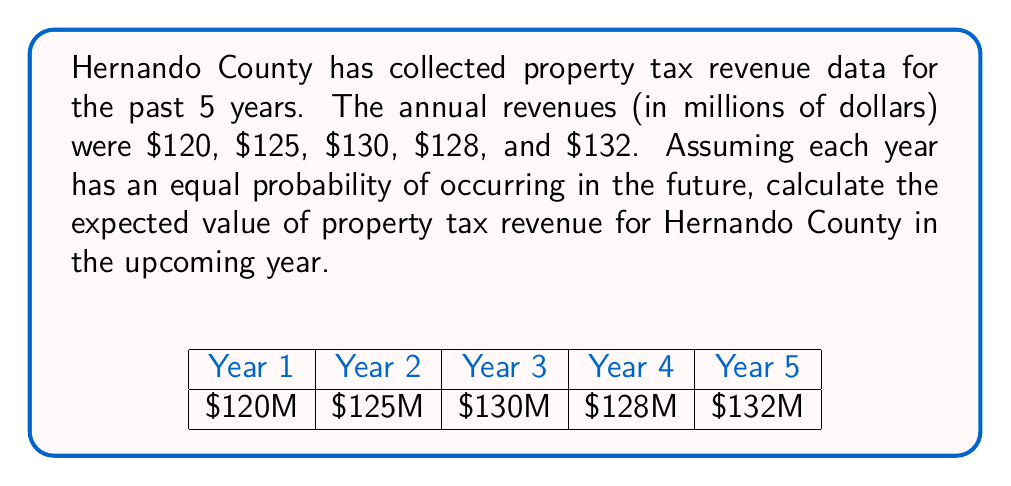What is the answer to this math problem? To calculate the expected value, we follow these steps:

1. Identify the possible outcomes and their probabilities:
   We have 5 years of data, each with an equal probability of 1/5.

2. Calculate the expected value using the formula:
   $$ E(X) = \sum_{i=1}^{n} x_i \cdot p(x_i) $$
   Where $x_i$ is each outcome and $p(x_i)$ is its probability.

3. Substitute the values:
   $$ E(X) = 120 \cdot \frac{1}{5} + 125 \cdot \frac{1}{5} + 130 \cdot \frac{1}{5} + 128 \cdot \frac{1}{5} + 132 \cdot \frac{1}{5} $$

4. Simplify:
   $$ E(X) = \frac{120 + 125 + 130 + 128 + 132}{5} = \frac{635}{5} = 127 $$

Therefore, the expected value of property tax revenue for Hernando County in the upcoming year is $127 million.
Answer: $127 million 